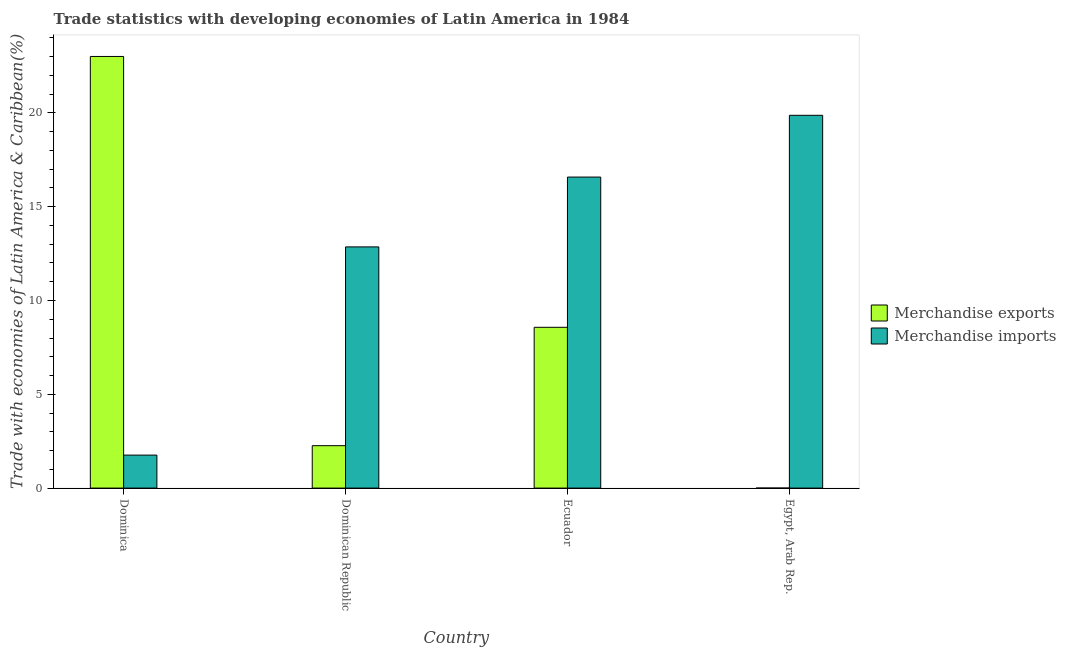How many groups of bars are there?
Your answer should be compact. 4. Are the number of bars on each tick of the X-axis equal?
Your answer should be very brief. Yes. What is the label of the 4th group of bars from the left?
Make the answer very short. Egypt, Arab Rep. In how many cases, is the number of bars for a given country not equal to the number of legend labels?
Your answer should be very brief. 0. What is the merchandise imports in Ecuador?
Offer a terse response. 16.58. Across all countries, what is the maximum merchandise exports?
Make the answer very short. 23.01. Across all countries, what is the minimum merchandise exports?
Give a very brief answer. 0. In which country was the merchandise exports maximum?
Provide a short and direct response. Dominica. In which country was the merchandise imports minimum?
Make the answer very short. Dominica. What is the total merchandise imports in the graph?
Offer a very short reply. 51.07. What is the difference between the merchandise exports in Dominica and that in Ecuador?
Your answer should be very brief. 14.44. What is the difference between the merchandise exports in Ecuador and the merchandise imports in Dominica?
Your answer should be very brief. 6.81. What is the average merchandise imports per country?
Offer a terse response. 12.77. What is the difference between the merchandise imports and merchandise exports in Egypt, Arab Rep.?
Keep it short and to the point. 19.87. In how many countries, is the merchandise imports greater than 16 %?
Make the answer very short. 2. What is the ratio of the merchandise imports in Dominican Republic to that in Ecuador?
Your response must be concise. 0.78. What is the difference between the highest and the second highest merchandise exports?
Offer a terse response. 14.44. What is the difference between the highest and the lowest merchandise exports?
Provide a succinct answer. 23.01. Is the sum of the merchandise exports in Dominica and Dominican Republic greater than the maximum merchandise imports across all countries?
Provide a succinct answer. Yes. What does the 1st bar from the left in Dominica represents?
Provide a succinct answer. Merchandise exports. What does the 1st bar from the right in Dominican Republic represents?
Offer a terse response. Merchandise imports. How many bars are there?
Make the answer very short. 8. What is the difference between two consecutive major ticks on the Y-axis?
Keep it short and to the point. 5. Does the graph contain grids?
Give a very brief answer. No. How many legend labels are there?
Provide a short and direct response. 2. What is the title of the graph?
Offer a terse response. Trade statistics with developing economies of Latin America in 1984. What is the label or title of the Y-axis?
Your answer should be very brief. Trade with economies of Latin America & Caribbean(%). What is the Trade with economies of Latin America & Caribbean(%) of Merchandise exports in Dominica?
Provide a succinct answer. 23.01. What is the Trade with economies of Latin America & Caribbean(%) in Merchandise imports in Dominica?
Keep it short and to the point. 1.76. What is the Trade with economies of Latin America & Caribbean(%) in Merchandise exports in Dominican Republic?
Provide a succinct answer. 2.26. What is the Trade with economies of Latin America & Caribbean(%) of Merchandise imports in Dominican Republic?
Ensure brevity in your answer.  12.86. What is the Trade with economies of Latin America & Caribbean(%) in Merchandise exports in Ecuador?
Ensure brevity in your answer.  8.57. What is the Trade with economies of Latin America & Caribbean(%) of Merchandise imports in Ecuador?
Offer a very short reply. 16.58. What is the Trade with economies of Latin America & Caribbean(%) in Merchandise exports in Egypt, Arab Rep.?
Offer a very short reply. 0. What is the Trade with economies of Latin America & Caribbean(%) of Merchandise imports in Egypt, Arab Rep.?
Offer a very short reply. 19.87. Across all countries, what is the maximum Trade with economies of Latin America & Caribbean(%) in Merchandise exports?
Your answer should be compact. 23.01. Across all countries, what is the maximum Trade with economies of Latin America & Caribbean(%) in Merchandise imports?
Ensure brevity in your answer.  19.87. Across all countries, what is the minimum Trade with economies of Latin America & Caribbean(%) in Merchandise exports?
Give a very brief answer. 0. Across all countries, what is the minimum Trade with economies of Latin America & Caribbean(%) in Merchandise imports?
Offer a terse response. 1.76. What is the total Trade with economies of Latin America & Caribbean(%) of Merchandise exports in the graph?
Give a very brief answer. 33.84. What is the total Trade with economies of Latin America & Caribbean(%) of Merchandise imports in the graph?
Provide a short and direct response. 51.07. What is the difference between the Trade with economies of Latin America & Caribbean(%) in Merchandise exports in Dominica and that in Dominican Republic?
Make the answer very short. 20.75. What is the difference between the Trade with economies of Latin America & Caribbean(%) in Merchandise imports in Dominica and that in Dominican Republic?
Your answer should be very brief. -11.1. What is the difference between the Trade with economies of Latin America & Caribbean(%) in Merchandise exports in Dominica and that in Ecuador?
Your response must be concise. 14.44. What is the difference between the Trade with economies of Latin America & Caribbean(%) in Merchandise imports in Dominica and that in Ecuador?
Offer a terse response. -14.82. What is the difference between the Trade with economies of Latin America & Caribbean(%) of Merchandise exports in Dominica and that in Egypt, Arab Rep.?
Offer a very short reply. 23.01. What is the difference between the Trade with economies of Latin America & Caribbean(%) in Merchandise imports in Dominica and that in Egypt, Arab Rep.?
Your answer should be compact. -18.11. What is the difference between the Trade with economies of Latin America & Caribbean(%) of Merchandise exports in Dominican Republic and that in Ecuador?
Your answer should be compact. -6.31. What is the difference between the Trade with economies of Latin America & Caribbean(%) in Merchandise imports in Dominican Republic and that in Ecuador?
Your answer should be very brief. -3.72. What is the difference between the Trade with economies of Latin America & Caribbean(%) in Merchandise exports in Dominican Republic and that in Egypt, Arab Rep.?
Offer a very short reply. 2.26. What is the difference between the Trade with economies of Latin America & Caribbean(%) of Merchandise imports in Dominican Republic and that in Egypt, Arab Rep.?
Keep it short and to the point. -7.01. What is the difference between the Trade with economies of Latin America & Caribbean(%) in Merchandise exports in Ecuador and that in Egypt, Arab Rep.?
Offer a terse response. 8.57. What is the difference between the Trade with economies of Latin America & Caribbean(%) in Merchandise imports in Ecuador and that in Egypt, Arab Rep.?
Offer a very short reply. -3.29. What is the difference between the Trade with economies of Latin America & Caribbean(%) in Merchandise exports in Dominica and the Trade with economies of Latin America & Caribbean(%) in Merchandise imports in Dominican Republic?
Your response must be concise. 10.15. What is the difference between the Trade with economies of Latin America & Caribbean(%) in Merchandise exports in Dominica and the Trade with economies of Latin America & Caribbean(%) in Merchandise imports in Ecuador?
Offer a terse response. 6.43. What is the difference between the Trade with economies of Latin America & Caribbean(%) in Merchandise exports in Dominica and the Trade with economies of Latin America & Caribbean(%) in Merchandise imports in Egypt, Arab Rep.?
Your response must be concise. 3.14. What is the difference between the Trade with economies of Latin America & Caribbean(%) in Merchandise exports in Dominican Republic and the Trade with economies of Latin America & Caribbean(%) in Merchandise imports in Ecuador?
Provide a succinct answer. -14.32. What is the difference between the Trade with economies of Latin America & Caribbean(%) of Merchandise exports in Dominican Republic and the Trade with economies of Latin America & Caribbean(%) of Merchandise imports in Egypt, Arab Rep.?
Provide a short and direct response. -17.61. What is the difference between the Trade with economies of Latin America & Caribbean(%) in Merchandise exports in Ecuador and the Trade with economies of Latin America & Caribbean(%) in Merchandise imports in Egypt, Arab Rep.?
Offer a terse response. -11.3. What is the average Trade with economies of Latin America & Caribbean(%) in Merchandise exports per country?
Offer a very short reply. 8.46. What is the average Trade with economies of Latin America & Caribbean(%) of Merchandise imports per country?
Provide a succinct answer. 12.77. What is the difference between the Trade with economies of Latin America & Caribbean(%) in Merchandise exports and Trade with economies of Latin America & Caribbean(%) in Merchandise imports in Dominica?
Provide a short and direct response. 21.25. What is the difference between the Trade with economies of Latin America & Caribbean(%) in Merchandise exports and Trade with economies of Latin America & Caribbean(%) in Merchandise imports in Dominican Republic?
Make the answer very short. -10.6. What is the difference between the Trade with economies of Latin America & Caribbean(%) of Merchandise exports and Trade with economies of Latin America & Caribbean(%) of Merchandise imports in Ecuador?
Your answer should be very brief. -8.01. What is the difference between the Trade with economies of Latin America & Caribbean(%) of Merchandise exports and Trade with economies of Latin America & Caribbean(%) of Merchandise imports in Egypt, Arab Rep.?
Your answer should be compact. -19.87. What is the ratio of the Trade with economies of Latin America & Caribbean(%) in Merchandise exports in Dominica to that in Dominican Republic?
Ensure brevity in your answer.  10.18. What is the ratio of the Trade with economies of Latin America & Caribbean(%) of Merchandise imports in Dominica to that in Dominican Republic?
Provide a succinct answer. 0.14. What is the ratio of the Trade with economies of Latin America & Caribbean(%) of Merchandise exports in Dominica to that in Ecuador?
Offer a very short reply. 2.68. What is the ratio of the Trade with economies of Latin America & Caribbean(%) of Merchandise imports in Dominica to that in Ecuador?
Your answer should be compact. 0.11. What is the ratio of the Trade with economies of Latin America & Caribbean(%) in Merchandise exports in Dominica to that in Egypt, Arab Rep.?
Your answer should be compact. 3.61e+04. What is the ratio of the Trade with economies of Latin America & Caribbean(%) of Merchandise imports in Dominica to that in Egypt, Arab Rep.?
Offer a very short reply. 0.09. What is the ratio of the Trade with economies of Latin America & Caribbean(%) of Merchandise exports in Dominican Republic to that in Ecuador?
Your answer should be compact. 0.26. What is the ratio of the Trade with economies of Latin America & Caribbean(%) of Merchandise imports in Dominican Republic to that in Ecuador?
Make the answer very short. 0.78. What is the ratio of the Trade with economies of Latin America & Caribbean(%) in Merchandise exports in Dominican Republic to that in Egypt, Arab Rep.?
Your answer should be compact. 3549.65. What is the ratio of the Trade with economies of Latin America & Caribbean(%) of Merchandise imports in Dominican Republic to that in Egypt, Arab Rep.?
Offer a very short reply. 0.65. What is the ratio of the Trade with economies of Latin America & Caribbean(%) of Merchandise exports in Ecuador to that in Egypt, Arab Rep.?
Ensure brevity in your answer.  1.35e+04. What is the ratio of the Trade with economies of Latin America & Caribbean(%) of Merchandise imports in Ecuador to that in Egypt, Arab Rep.?
Your answer should be very brief. 0.83. What is the difference between the highest and the second highest Trade with economies of Latin America & Caribbean(%) of Merchandise exports?
Offer a very short reply. 14.44. What is the difference between the highest and the second highest Trade with economies of Latin America & Caribbean(%) in Merchandise imports?
Offer a very short reply. 3.29. What is the difference between the highest and the lowest Trade with economies of Latin America & Caribbean(%) in Merchandise exports?
Provide a succinct answer. 23.01. What is the difference between the highest and the lowest Trade with economies of Latin America & Caribbean(%) in Merchandise imports?
Keep it short and to the point. 18.11. 